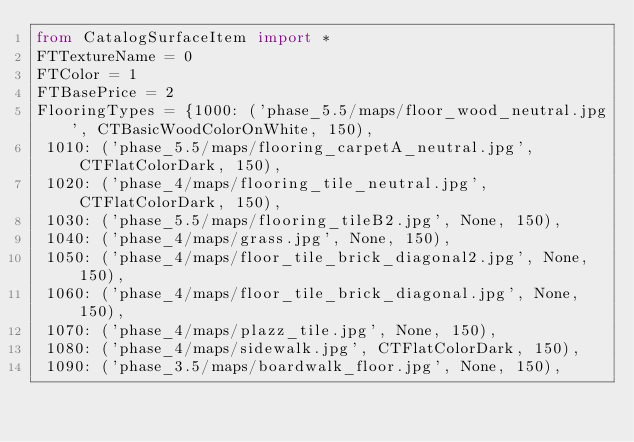<code> <loc_0><loc_0><loc_500><loc_500><_Python_>from CatalogSurfaceItem import *
FTTextureName = 0
FTColor = 1
FTBasePrice = 2
FlooringTypes = {1000: ('phase_5.5/maps/floor_wood_neutral.jpg', CTBasicWoodColorOnWhite, 150),
 1010: ('phase_5.5/maps/flooring_carpetA_neutral.jpg', CTFlatColorDark, 150),
 1020: ('phase_4/maps/flooring_tile_neutral.jpg', CTFlatColorDark, 150),
 1030: ('phase_5.5/maps/flooring_tileB2.jpg', None, 150),
 1040: ('phase_4/maps/grass.jpg', None, 150),
 1050: ('phase_4/maps/floor_tile_brick_diagonal2.jpg', None, 150),
 1060: ('phase_4/maps/floor_tile_brick_diagonal.jpg', None, 150),
 1070: ('phase_4/maps/plazz_tile.jpg', None, 150),
 1080: ('phase_4/maps/sidewalk.jpg', CTFlatColorDark, 150),
 1090: ('phase_3.5/maps/boardwalk_floor.jpg', None, 150),</code> 